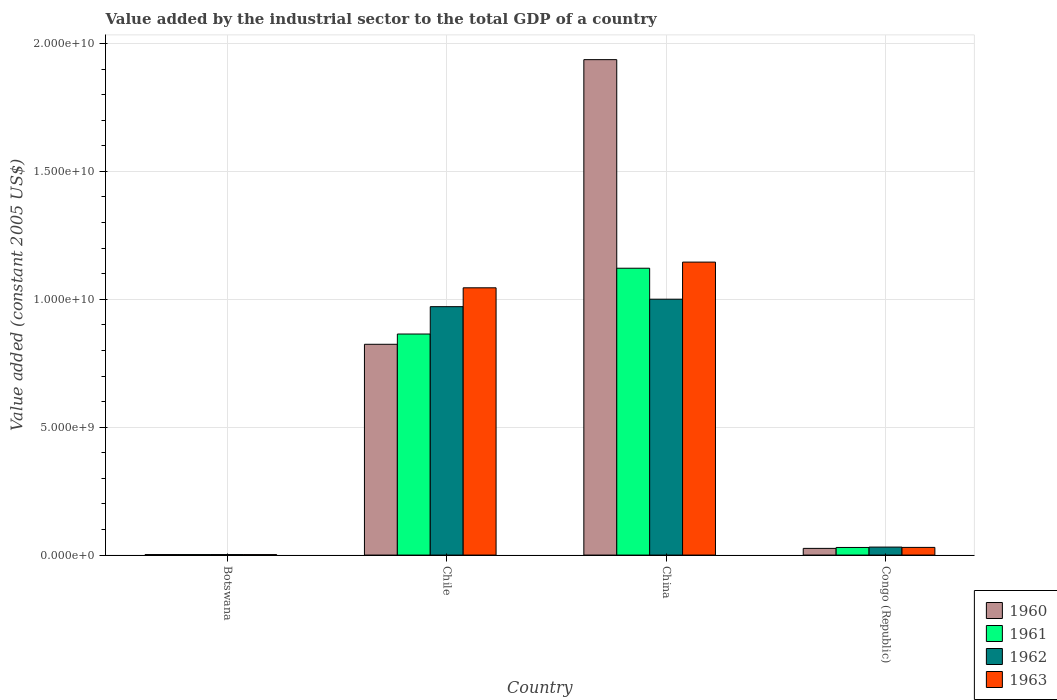How many different coloured bars are there?
Ensure brevity in your answer.  4. What is the label of the 4th group of bars from the left?
Your answer should be compact. Congo (Republic). In how many cases, is the number of bars for a given country not equal to the number of legend labels?
Offer a terse response. 0. What is the value added by the industrial sector in 1963 in Botswana?
Offer a very short reply. 1.83e+07. Across all countries, what is the maximum value added by the industrial sector in 1961?
Provide a short and direct response. 1.12e+1. Across all countries, what is the minimum value added by the industrial sector in 1961?
Make the answer very short. 1.92e+07. In which country was the value added by the industrial sector in 1963 maximum?
Keep it short and to the point. China. In which country was the value added by the industrial sector in 1962 minimum?
Offer a terse response. Botswana. What is the total value added by the industrial sector in 1961 in the graph?
Provide a succinct answer. 2.02e+1. What is the difference between the value added by the industrial sector in 1963 in Chile and that in China?
Offer a very short reply. -1.01e+09. What is the difference between the value added by the industrial sector in 1960 in China and the value added by the industrial sector in 1961 in Congo (Republic)?
Give a very brief answer. 1.91e+1. What is the average value added by the industrial sector in 1963 per country?
Make the answer very short. 5.55e+09. What is the difference between the value added by the industrial sector of/in 1960 and value added by the industrial sector of/in 1961 in Congo (Republic)?
Your answer should be compact. -3.63e+07. In how many countries, is the value added by the industrial sector in 1960 greater than 16000000000 US$?
Keep it short and to the point. 1. What is the ratio of the value added by the industrial sector in 1963 in Chile to that in China?
Provide a short and direct response. 0.91. What is the difference between the highest and the second highest value added by the industrial sector in 1962?
Your answer should be compact. 9.40e+09. What is the difference between the highest and the lowest value added by the industrial sector in 1961?
Your answer should be very brief. 1.12e+1. Is the sum of the value added by the industrial sector in 1963 in China and Congo (Republic) greater than the maximum value added by the industrial sector in 1961 across all countries?
Ensure brevity in your answer.  Yes. How many bars are there?
Provide a short and direct response. 16. Are all the bars in the graph horizontal?
Your response must be concise. No. How many countries are there in the graph?
Your response must be concise. 4. Are the values on the major ticks of Y-axis written in scientific E-notation?
Ensure brevity in your answer.  Yes. Does the graph contain grids?
Offer a very short reply. Yes. How are the legend labels stacked?
Your answer should be compact. Vertical. What is the title of the graph?
Provide a short and direct response. Value added by the industrial sector to the total GDP of a country. Does "2003" appear as one of the legend labels in the graph?
Your answer should be very brief. No. What is the label or title of the Y-axis?
Provide a short and direct response. Value added (constant 2005 US$). What is the Value added (constant 2005 US$) of 1960 in Botswana?
Make the answer very short. 1.96e+07. What is the Value added (constant 2005 US$) of 1961 in Botswana?
Keep it short and to the point. 1.92e+07. What is the Value added (constant 2005 US$) in 1962 in Botswana?
Offer a very short reply. 1.98e+07. What is the Value added (constant 2005 US$) in 1963 in Botswana?
Keep it short and to the point. 1.83e+07. What is the Value added (constant 2005 US$) of 1960 in Chile?
Your answer should be very brief. 8.24e+09. What is the Value added (constant 2005 US$) of 1961 in Chile?
Your response must be concise. 8.64e+09. What is the Value added (constant 2005 US$) of 1962 in Chile?
Provide a short and direct response. 9.71e+09. What is the Value added (constant 2005 US$) of 1963 in Chile?
Offer a very short reply. 1.04e+1. What is the Value added (constant 2005 US$) in 1960 in China?
Give a very brief answer. 1.94e+1. What is the Value added (constant 2005 US$) of 1961 in China?
Offer a terse response. 1.12e+1. What is the Value added (constant 2005 US$) in 1962 in China?
Your response must be concise. 1.00e+1. What is the Value added (constant 2005 US$) in 1963 in China?
Your answer should be very brief. 1.15e+1. What is the Value added (constant 2005 US$) in 1960 in Congo (Republic)?
Your answer should be compact. 2.61e+08. What is the Value added (constant 2005 US$) in 1961 in Congo (Republic)?
Offer a very short reply. 2.98e+08. What is the Value added (constant 2005 US$) of 1962 in Congo (Republic)?
Your answer should be very brief. 3.12e+08. What is the Value added (constant 2005 US$) in 1963 in Congo (Republic)?
Offer a terse response. 3.00e+08. Across all countries, what is the maximum Value added (constant 2005 US$) in 1960?
Provide a short and direct response. 1.94e+1. Across all countries, what is the maximum Value added (constant 2005 US$) in 1961?
Provide a short and direct response. 1.12e+1. Across all countries, what is the maximum Value added (constant 2005 US$) in 1962?
Provide a short and direct response. 1.00e+1. Across all countries, what is the maximum Value added (constant 2005 US$) of 1963?
Offer a terse response. 1.15e+1. Across all countries, what is the minimum Value added (constant 2005 US$) of 1960?
Keep it short and to the point. 1.96e+07. Across all countries, what is the minimum Value added (constant 2005 US$) of 1961?
Offer a terse response. 1.92e+07. Across all countries, what is the minimum Value added (constant 2005 US$) in 1962?
Your response must be concise. 1.98e+07. Across all countries, what is the minimum Value added (constant 2005 US$) in 1963?
Offer a very short reply. 1.83e+07. What is the total Value added (constant 2005 US$) of 1960 in the graph?
Give a very brief answer. 2.79e+1. What is the total Value added (constant 2005 US$) of 1961 in the graph?
Keep it short and to the point. 2.02e+1. What is the total Value added (constant 2005 US$) in 1962 in the graph?
Your answer should be very brief. 2.00e+1. What is the total Value added (constant 2005 US$) of 1963 in the graph?
Keep it short and to the point. 2.22e+1. What is the difference between the Value added (constant 2005 US$) of 1960 in Botswana and that in Chile?
Your answer should be very brief. -8.22e+09. What is the difference between the Value added (constant 2005 US$) of 1961 in Botswana and that in Chile?
Your response must be concise. -8.62e+09. What is the difference between the Value added (constant 2005 US$) of 1962 in Botswana and that in Chile?
Your response must be concise. -9.69e+09. What is the difference between the Value added (constant 2005 US$) of 1963 in Botswana and that in Chile?
Keep it short and to the point. -1.04e+1. What is the difference between the Value added (constant 2005 US$) of 1960 in Botswana and that in China?
Offer a terse response. -1.93e+1. What is the difference between the Value added (constant 2005 US$) in 1961 in Botswana and that in China?
Offer a very short reply. -1.12e+1. What is the difference between the Value added (constant 2005 US$) in 1962 in Botswana and that in China?
Ensure brevity in your answer.  -9.98e+09. What is the difference between the Value added (constant 2005 US$) of 1963 in Botswana and that in China?
Keep it short and to the point. -1.14e+1. What is the difference between the Value added (constant 2005 US$) in 1960 in Botswana and that in Congo (Republic)?
Ensure brevity in your answer.  -2.42e+08. What is the difference between the Value added (constant 2005 US$) in 1961 in Botswana and that in Congo (Republic)?
Your answer should be very brief. -2.78e+08. What is the difference between the Value added (constant 2005 US$) in 1962 in Botswana and that in Congo (Republic)?
Provide a short and direct response. -2.93e+08. What is the difference between the Value added (constant 2005 US$) in 1963 in Botswana and that in Congo (Republic)?
Provide a succinct answer. -2.81e+08. What is the difference between the Value added (constant 2005 US$) of 1960 in Chile and that in China?
Offer a terse response. -1.11e+1. What is the difference between the Value added (constant 2005 US$) of 1961 in Chile and that in China?
Offer a very short reply. -2.57e+09. What is the difference between the Value added (constant 2005 US$) in 1962 in Chile and that in China?
Offer a terse response. -2.92e+08. What is the difference between the Value added (constant 2005 US$) of 1963 in Chile and that in China?
Your response must be concise. -1.01e+09. What is the difference between the Value added (constant 2005 US$) in 1960 in Chile and that in Congo (Republic)?
Your response must be concise. 7.98e+09. What is the difference between the Value added (constant 2005 US$) in 1961 in Chile and that in Congo (Republic)?
Your answer should be very brief. 8.34e+09. What is the difference between the Value added (constant 2005 US$) in 1962 in Chile and that in Congo (Republic)?
Keep it short and to the point. 9.40e+09. What is the difference between the Value added (constant 2005 US$) of 1963 in Chile and that in Congo (Republic)?
Provide a succinct answer. 1.01e+1. What is the difference between the Value added (constant 2005 US$) of 1960 in China and that in Congo (Republic)?
Give a very brief answer. 1.91e+1. What is the difference between the Value added (constant 2005 US$) in 1961 in China and that in Congo (Republic)?
Offer a very short reply. 1.09e+1. What is the difference between the Value added (constant 2005 US$) of 1962 in China and that in Congo (Republic)?
Your answer should be very brief. 9.69e+09. What is the difference between the Value added (constant 2005 US$) of 1963 in China and that in Congo (Republic)?
Your response must be concise. 1.12e+1. What is the difference between the Value added (constant 2005 US$) of 1960 in Botswana and the Value added (constant 2005 US$) of 1961 in Chile?
Give a very brief answer. -8.62e+09. What is the difference between the Value added (constant 2005 US$) in 1960 in Botswana and the Value added (constant 2005 US$) in 1962 in Chile?
Your answer should be compact. -9.69e+09. What is the difference between the Value added (constant 2005 US$) of 1960 in Botswana and the Value added (constant 2005 US$) of 1963 in Chile?
Give a very brief answer. -1.04e+1. What is the difference between the Value added (constant 2005 US$) of 1961 in Botswana and the Value added (constant 2005 US$) of 1962 in Chile?
Provide a short and direct response. -9.69e+09. What is the difference between the Value added (constant 2005 US$) of 1961 in Botswana and the Value added (constant 2005 US$) of 1963 in Chile?
Ensure brevity in your answer.  -1.04e+1. What is the difference between the Value added (constant 2005 US$) of 1962 in Botswana and the Value added (constant 2005 US$) of 1963 in Chile?
Your answer should be compact. -1.04e+1. What is the difference between the Value added (constant 2005 US$) of 1960 in Botswana and the Value added (constant 2005 US$) of 1961 in China?
Keep it short and to the point. -1.12e+1. What is the difference between the Value added (constant 2005 US$) in 1960 in Botswana and the Value added (constant 2005 US$) in 1962 in China?
Your answer should be very brief. -9.98e+09. What is the difference between the Value added (constant 2005 US$) of 1960 in Botswana and the Value added (constant 2005 US$) of 1963 in China?
Provide a short and direct response. -1.14e+1. What is the difference between the Value added (constant 2005 US$) in 1961 in Botswana and the Value added (constant 2005 US$) in 1962 in China?
Keep it short and to the point. -9.98e+09. What is the difference between the Value added (constant 2005 US$) in 1961 in Botswana and the Value added (constant 2005 US$) in 1963 in China?
Make the answer very short. -1.14e+1. What is the difference between the Value added (constant 2005 US$) of 1962 in Botswana and the Value added (constant 2005 US$) of 1963 in China?
Your answer should be very brief. -1.14e+1. What is the difference between the Value added (constant 2005 US$) of 1960 in Botswana and the Value added (constant 2005 US$) of 1961 in Congo (Republic)?
Make the answer very short. -2.78e+08. What is the difference between the Value added (constant 2005 US$) in 1960 in Botswana and the Value added (constant 2005 US$) in 1962 in Congo (Republic)?
Offer a very short reply. -2.93e+08. What is the difference between the Value added (constant 2005 US$) in 1960 in Botswana and the Value added (constant 2005 US$) in 1963 in Congo (Republic)?
Offer a terse response. -2.80e+08. What is the difference between the Value added (constant 2005 US$) of 1961 in Botswana and the Value added (constant 2005 US$) of 1962 in Congo (Republic)?
Your answer should be very brief. -2.93e+08. What is the difference between the Value added (constant 2005 US$) in 1961 in Botswana and the Value added (constant 2005 US$) in 1963 in Congo (Republic)?
Provide a short and direct response. -2.81e+08. What is the difference between the Value added (constant 2005 US$) of 1962 in Botswana and the Value added (constant 2005 US$) of 1963 in Congo (Republic)?
Keep it short and to the point. -2.80e+08. What is the difference between the Value added (constant 2005 US$) in 1960 in Chile and the Value added (constant 2005 US$) in 1961 in China?
Ensure brevity in your answer.  -2.97e+09. What is the difference between the Value added (constant 2005 US$) in 1960 in Chile and the Value added (constant 2005 US$) in 1962 in China?
Provide a succinct answer. -1.76e+09. What is the difference between the Value added (constant 2005 US$) in 1960 in Chile and the Value added (constant 2005 US$) in 1963 in China?
Give a very brief answer. -3.21e+09. What is the difference between the Value added (constant 2005 US$) of 1961 in Chile and the Value added (constant 2005 US$) of 1962 in China?
Keep it short and to the point. -1.36e+09. What is the difference between the Value added (constant 2005 US$) in 1961 in Chile and the Value added (constant 2005 US$) in 1963 in China?
Your answer should be very brief. -2.81e+09. What is the difference between the Value added (constant 2005 US$) of 1962 in Chile and the Value added (constant 2005 US$) of 1963 in China?
Your answer should be compact. -1.74e+09. What is the difference between the Value added (constant 2005 US$) of 1960 in Chile and the Value added (constant 2005 US$) of 1961 in Congo (Republic)?
Give a very brief answer. 7.94e+09. What is the difference between the Value added (constant 2005 US$) of 1960 in Chile and the Value added (constant 2005 US$) of 1962 in Congo (Republic)?
Your response must be concise. 7.93e+09. What is the difference between the Value added (constant 2005 US$) of 1960 in Chile and the Value added (constant 2005 US$) of 1963 in Congo (Republic)?
Ensure brevity in your answer.  7.94e+09. What is the difference between the Value added (constant 2005 US$) of 1961 in Chile and the Value added (constant 2005 US$) of 1962 in Congo (Republic)?
Offer a terse response. 8.33e+09. What is the difference between the Value added (constant 2005 US$) of 1961 in Chile and the Value added (constant 2005 US$) of 1963 in Congo (Republic)?
Your response must be concise. 8.34e+09. What is the difference between the Value added (constant 2005 US$) of 1962 in Chile and the Value added (constant 2005 US$) of 1963 in Congo (Republic)?
Ensure brevity in your answer.  9.41e+09. What is the difference between the Value added (constant 2005 US$) of 1960 in China and the Value added (constant 2005 US$) of 1961 in Congo (Republic)?
Keep it short and to the point. 1.91e+1. What is the difference between the Value added (constant 2005 US$) of 1960 in China and the Value added (constant 2005 US$) of 1962 in Congo (Republic)?
Provide a short and direct response. 1.91e+1. What is the difference between the Value added (constant 2005 US$) of 1960 in China and the Value added (constant 2005 US$) of 1963 in Congo (Republic)?
Offer a terse response. 1.91e+1. What is the difference between the Value added (constant 2005 US$) in 1961 in China and the Value added (constant 2005 US$) in 1962 in Congo (Republic)?
Ensure brevity in your answer.  1.09e+1. What is the difference between the Value added (constant 2005 US$) in 1961 in China and the Value added (constant 2005 US$) in 1963 in Congo (Republic)?
Your response must be concise. 1.09e+1. What is the difference between the Value added (constant 2005 US$) in 1962 in China and the Value added (constant 2005 US$) in 1963 in Congo (Republic)?
Your answer should be compact. 9.70e+09. What is the average Value added (constant 2005 US$) of 1960 per country?
Ensure brevity in your answer.  6.97e+09. What is the average Value added (constant 2005 US$) of 1961 per country?
Offer a very short reply. 5.04e+09. What is the average Value added (constant 2005 US$) in 1962 per country?
Give a very brief answer. 5.01e+09. What is the average Value added (constant 2005 US$) in 1963 per country?
Your answer should be very brief. 5.55e+09. What is the difference between the Value added (constant 2005 US$) in 1960 and Value added (constant 2005 US$) in 1961 in Botswana?
Your answer should be very brief. 4.24e+05. What is the difference between the Value added (constant 2005 US$) in 1960 and Value added (constant 2005 US$) in 1962 in Botswana?
Give a very brief answer. -2.12e+05. What is the difference between the Value added (constant 2005 US$) of 1960 and Value added (constant 2005 US$) of 1963 in Botswana?
Ensure brevity in your answer.  1.27e+06. What is the difference between the Value added (constant 2005 US$) in 1961 and Value added (constant 2005 US$) in 1962 in Botswana?
Provide a succinct answer. -6.36e+05. What is the difference between the Value added (constant 2005 US$) of 1961 and Value added (constant 2005 US$) of 1963 in Botswana?
Your answer should be compact. 8.48e+05. What is the difference between the Value added (constant 2005 US$) in 1962 and Value added (constant 2005 US$) in 1963 in Botswana?
Offer a very short reply. 1.48e+06. What is the difference between the Value added (constant 2005 US$) of 1960 and Value added (constant 2005 US$) of 1961 in Chile?
Offer a very short reply. -4.01e+08. What is the difference between the Value added (constant 2005 US$) of 1960 and Value added (constant 2005 US$) of 1962 in Chile?
Provide a short and direct response. -1.47e+09. What is the difference between the Value added (constant 2005 US$) of 1960 and Value added (constant 2005 US$) of 1963 in Chile?
Provide a short and direct response. -2.21e+09. What is the difference between the Value added (constant 2005 US$) of 1961 and Value added (constant 2005 US$) of 1962 in Chile?
Your answer should be very brief. -1.07e+09. What is the difference between the Value added (constant 2005 US$) of 1961 and Value added (constant 2005 US$) of 1963 in Chile?
Provide a short and direct response. -1.81e+09. What is the difference between the Value added (constant 2005 US$) in 1962 and Value added (constant 2005 US$) in 1963 in Chile?
Provide a short and direct response. -7.37e+08. What is the difference between the Value added (constant 2005 US$) of 1960 and Value added (constant 2005 US$) of 1961 in China?
Your answer should be very brief. 8.15e+09. What is the difference between the Value added (constant 2005 US$) of 1960 and Value added (constant 2005 US$) of 1962 in China?
Make the answer very short. 9.36e+09. What is the difference between the Value added (constant 2005 US$) of 1960 and Value added (constant 2005 US$) of 1963 in China?
Provide a succinct answer. 7.91e+09. What is the difference between the Value added (constant 2005 US$) in 1961 and Value added (constant 2005 US$) in 1962 in China?
Ensure brevity in your answer.  1.21e+09. What is the difference between the Value added (constant 2005 US$) in 1961 and Value added (constant 2005 US$) in 1963 in China?
Make the answer very short. -2.39e+08. What is the difference between the Value added (constant 2005 US$) in 1962 and Value added (constant 2005 US$) in 1963 in China?
Offer a terse response. -1.45e+09. What is the difference between the Value added (constant 2005 US$) in 1960 and Value added (constant 2005 US$) in 1961 in Congo (Republic)?
Offer a very short reply. -3.63e+07. What is the difference between the Value added (constant 2005 US$) in 1960 and Value added (constant 2005 US$) in 1962 in Congo (Republic)?
Make the answer very short. -5.10e+07. What is the difference between the Value added (constant 2005 US$) of 1960 and Value added (constant 2005 US$) of 1963 in Congo (Republic)?
Your response must be concise. -3.84e+07. What is the difference between the Value added (constant 2005 US$) in 1961 and Value added (constant 2005 US$) in 1962 in Congo (Republic)?
Ensure brevity in your answer.  -1.47e+07. What is the difference between the Value added (constant 2005 US$) of 1961 and Value added (constant 2005 US$) of 1963 in Congo (Republic)?
Your answer should be very brief. -2.10e+06. What is the difference between the Value added (constant 2005 US$) of 1962 and Value added (constant 2005 US$) of 1963 in Congo (Republic)?
Offer a terse response. 1.26e+07. What is the ratio of the Value added (constant 2005 US$) of 1960 in Botswana to that in Chile?
Your answer should be very brief. 0. What is the ratio of the Value added (constant 2005 US$) in 1961 in Botswana to that in Chile?
Make the answer very short. 0. What is the ratio of the Value added (constant 2005 US$) in 1962 in Botswana to that in Chile?
Provide a succinct answer. 0. What is the ratio of the Value added (constant 2005 US$) of 1963 in Botswana to that in Chile?
Your answer should be compact. 0. What is the ratio of the Value added (constant 2005 US$) in 1961 in Botswana to that in China?
Your response must be concise. 0. What is the ratio of the Value added (constant 2005 US$) of 1962 in Botswana to that in China?
Offer a terse response. 0. What is the ratio of the Value added (constant 2005 US$) of 1963 in Botswana to that in China?
Give a very brief answer. 0. What is the ratio of the Value added (constant 2005 US$) in 1960 in Botswana to that in Congo (Republic)?
Your response must be concise. 0.07. What is the ratio of the Value added (constant 2005 US$) of 1961 in Botswana to that in Congo (Republic)?
Make the answer very short. 0.06. What is the ratio of the Value added (constant 2005 US$) of 1962 in Botswana to that in Congo (Republic)?
Provide a short and direct response. 0.06. What is the ratio of the Value added (constant 2005 US$) of 1963 in Botswana to that in Congo (Republic)?
Offer a very short reply. 0.06. What is the ratio of the Value added (constant 2005 US$) in 1960 in Chile to that in China?
Offer a terse response. 0.43. What is the ratio of the Value added (constant 2005 US$) of 1961 in Chile to that in China?
Ensure brevity in your answer.  0.77. What is the ratio of the Value added (constant 2005 US$) in 1962 in Chile to that in China?
Give a very brief answer. 0.97. What is the ratio of the Value added (constant 2005 US$) of 1963 in Chile to that in China?
Provide a short and direct response. 0.91. What is the ratio of the Value added (constant 2005 US$) of 1960 in Chile to that in Congo (Republic)?
Your answer should be compact. 31.52. What is the ratio of the Value added (constant 2005 US$) of 1961 in Chile to that in Congo (Republic)?
Make the answer very short. 29.03. What is the ratio of the Value added (constant 2005 US$) in 1962 in Chile to that in Congo (Republic)?
Your response must be concise. 31.09. What is the ratio of the Value added (constant 2005 US$) of 1963 in Chile to that in Congo (Republic)?
Provide a succinct answer. 34.85. What is the ratio of the Value added (constant 2005 US$) in 1960 in China to that in Congo (Republic)?
Provide a succinct answer. 74.09. What is the ratio of the Value added (constant 2005 US$) in 1961 in China to that in Congo (Republic)?
Make the answer very short. 37.67. What is the ratio of the Value added (constant 2005 US$) of 1962 in China to that in Congo (Republic)?
Offer a terse response. 32.02. What is the ratio of the Value added (constant 2005 US$) of 1963 in China to that in Congo (Republic)?
Give a very brief answer. 38.21. What is the difference between the highest and the second highest Value added (constant 2005 US$) of 1960?
Provide a succinct answer. 1.11e+1. What is the difference between the highest and the second highest Value added (constant 2005 US$) in 1961?
Your answer should be compact. 2.57e+09. What is the difference between the highest and the second highest Value added (constant 2005 US$) of 1962?
Provide a succinct answer. 2.92e+08. What is the difference between the highest and the second highest Value added (constant 2005 US$) of 1963?
Keep it short and to the point. 1.01e+09. What is the difference between the highest and the lowest Value added (constant 2005 US$) of 1960?
Provide a short and direct response. 1.93e+1. What is the difference between the highest and the lowest Value added (constant 2005 US$) in 1961?
Offer a very short reply. 1.12e+1. What is the difference between the highest and the lowest Value added (constant 2005 US$) of 1962?
Give a very brief answer. 9.98e+09. What is the difference between the highest and the lowest Value added (constant 2005 US$) of 1963?
Offer a very short reply. 1.14e+1. 